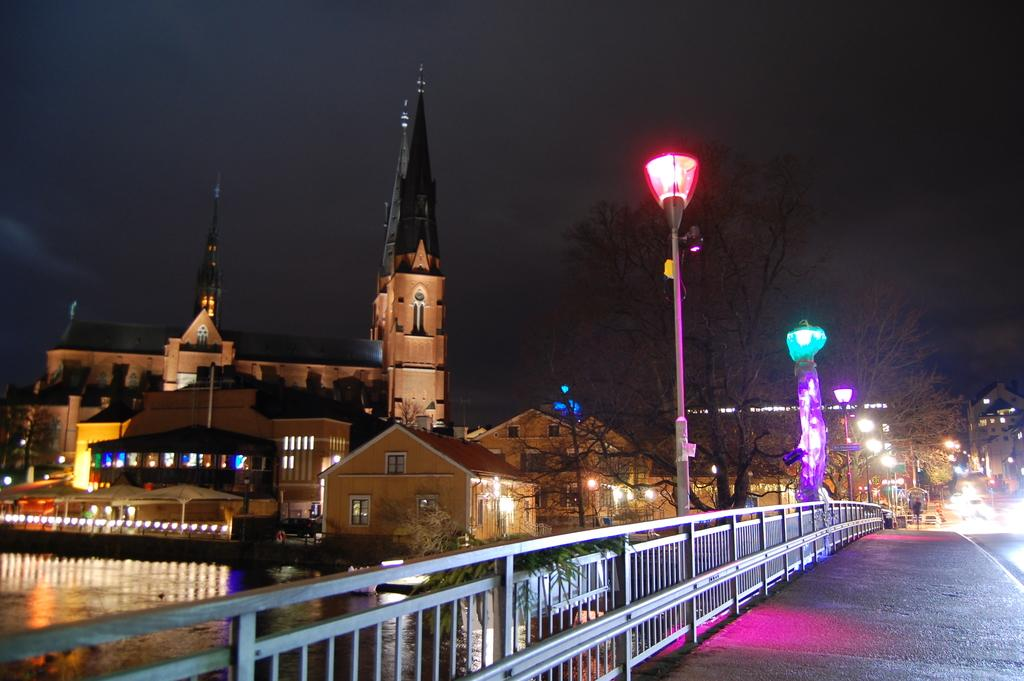What natural feature is present in the image? There is a river with water flowing in the image. What type of man-made structures can be seen in the image? There are buildings with windows and lights in the image. What connects the two sides of the river in the image? There is a bridge in the image. What type of vegetation is present in the image? There are trees in the image. What safety measures are present in the image? There are barricades in the image. What type of drain is visible in the image? There is no drain present in the image. What type of war is being depicted in the image? There is no war being depicted in the image; it features a river, buildings, a bridge, trees, and barricades. How many beds are visible in the image? There are no beds present in the image. 